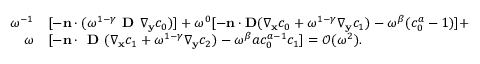<formula> <loc_0><loc_0><loc_500><loc_500>\begin{array} { r l } { \omega ^ { - 1 } } & { [ - \mathbf n \cdot ( \omega ^ { 1 - \gamma } D \nabla _ { \mathbf y } c _ { 0 } ) ] + \omega ^ { 0 } [ - \mathbf n \cdot \mathbf D ( \nabla _ { \mathbf x } c _ { 0 } + \omega ^ { 1 - \gamma } \nabla _ { \mathbf y } c _ { 1 } ) - \omega ^ { \beta } ( c _ { 0 } ^ { a } - 1 ) ] + } \\ { \omega } & { [ - \mathbf n \cdot D ( \nabla _ { \mathbf x } c _ { 1 } + \omega ^ { 1 - \gamma } \nabla _ { \mathbf y } c _ { 2 } ) - \omega ^ { \beta } a c _ { 0 } ^ { a - 1 } c _ { 1 } ] = \mathcal { O } ( \omega ^ { 2 } ) . } \end{array}</formula> 